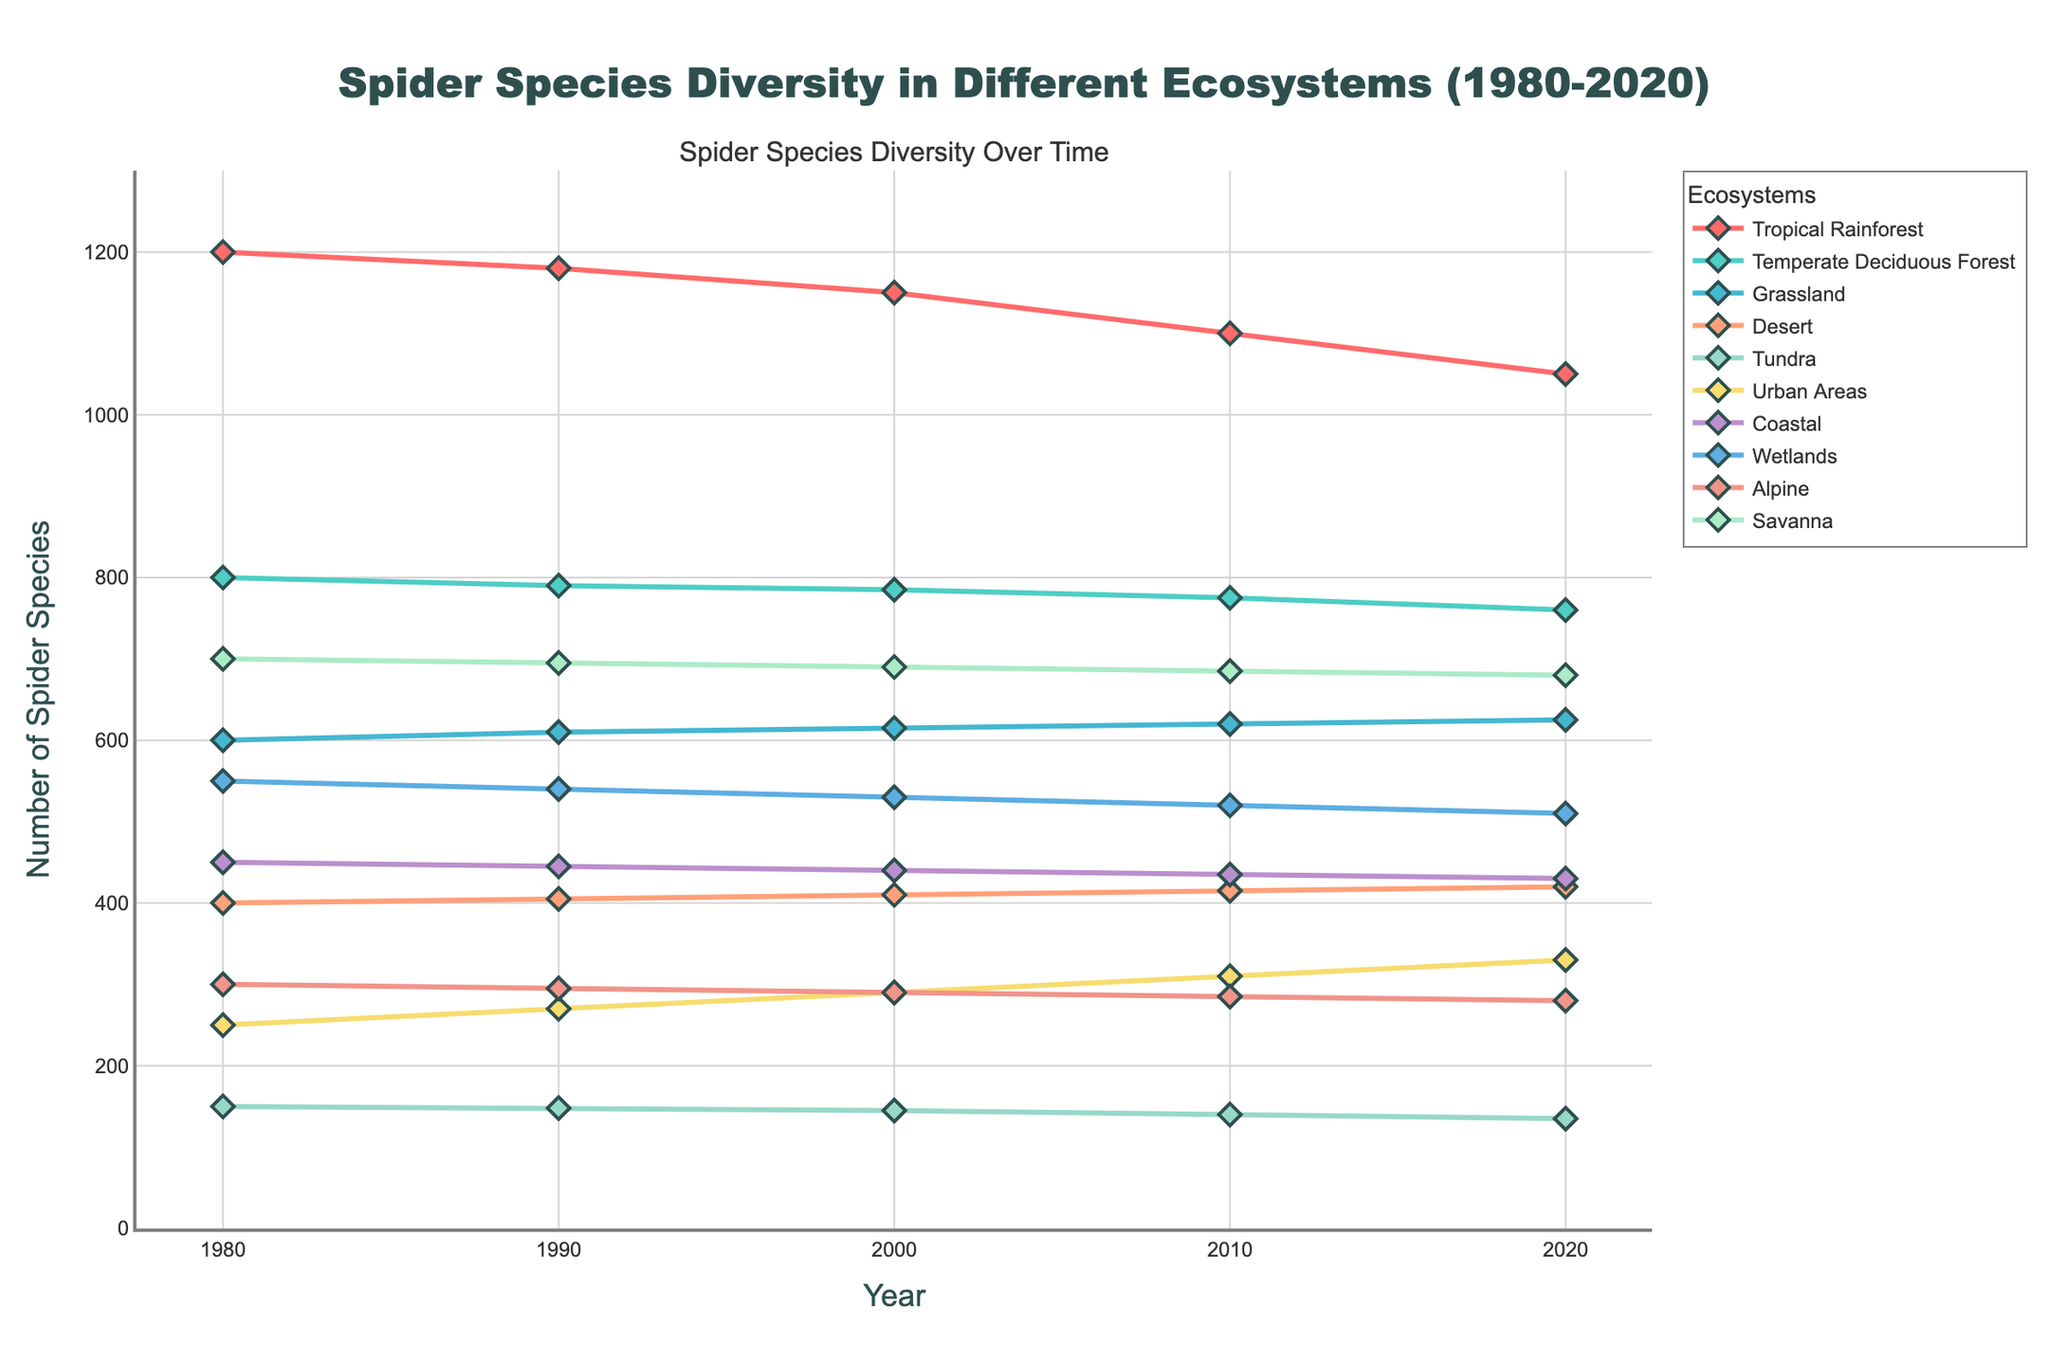Which ecosystem shows the most significant decline in spider species diversity between 1980 and 2020? Look at the lines representing different ecosystems and compare their starting points in 1980 and ending points in 2020. The Tropical Rainforest shows the largest decrease, from 1200 to 1050, a decline of 150 species.
Answer: Tropical Rainforest Which ecosystem shows a continuous increase in spider species diversity from 1980 to 2020? Identify the lines that only move upward as time progresses. The line representing Urban Areas rises consistently from 250 in 1980 to 330 in 2020, indicating a continuous increase in species diversity.
Answer: Urban Areas How many ecosystems have a higher spider species diversity than Grassland in 2000? Locate the value for Grassland in 2000 (615) and count the ecosystems with values higher than this. Tropical Rainforest, Temperate Deciduous Forest, and Savanna all have higher values, making a total of three ecosystems.
Answer: Three By how much does the spider species diversity in Tropical Rainforest decrease between 1980 and 2020? Subtract the value for Tropical Rainforest in 2020 (1050) from its value in 1980 (1200). The decrease is 1200 - 1050 = 150 species.
Answer: 150 In which year is the spider species diversity in Urban Areas equal to that in Tundra in 1980? Find the value for Tundra in 1980 (150) and locate the year when Urban Areas reach this value. In 1980, Urban Areas already have 250 species, exceeding 150, so the figure does not show such a year.
Answer: Not applicable What is the average spider species diversity in Coastal areas across all years provided? Sum the values for Coastal in each year (450 + 445 + 440 + 435 + 430 = 2200) and divide by the number of years (5). The average is 2200 / 5 = 440.
Answer: 440 Which ecosystem experienced the least change in spider species diversity from 1980 to 2020? Identify the ecosystems where the values for 1980 and 2020 are closest. For Desert, the values are 400 in 1980 and 420 in 2020, a change of only 20 species.
Answer: Desert What is the total spider species diversity for all ecosystems combined in 2020? Sum the spider species diversity values for all ecosystems in 2020 (1050 + 760 + 625 + 420 + 135 + 330 + 430 + 510 + 280 + 680 = 5220).
Answer: 5220 How does the decrease in spider species diversity in Wetlands from 1980 to 2020 compare to that in Alpine? Calculate the decrease for Wetlands (550 - 510 = 40) and for Alpine (300 - 280 = 20). Wetlands experienced a larger decrease of 20 more species compared to Alpine.
Answer: 20 more species 